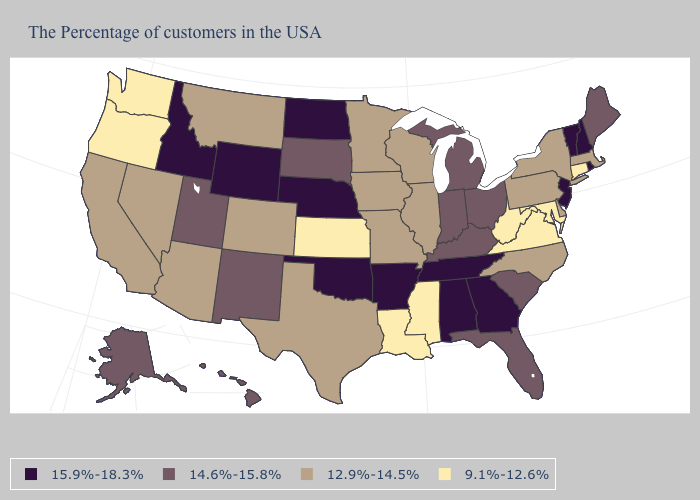Name the states that have a value in the range 15.9%-18.3%?
Concise answer only. Rhode Island, New Hampshire, Vermont, New Jersey, Georgia, Alabama, Tennessee, Arkansas, Nebraska, Oklahoma, North Dakota, Wyoming, Idaho. Name the states that have a value in the range 12.9%-14.5%?
Keep it brief. Massachusetts, New York, Delaware, Pennsylvania, North Carolina, Wisconsin, Illinois, Missouri, Minnesota, Iowa, Texas, Colorado, Montana, Arizona, Nevada, California. Name the states that have a value in the range 9.1%-12.6%?
Answer briefly. Connecticut, Maryland, Virginia, West Virginia, Mississippi, Louisiana, Kansas, Washington, Oregon. Among the states that border Rhode Island , does Connecticut have the lowest value?
Be succinct. Yes. Among the states that border Kansas , which have the highest value?
Concise answer only. Nebraska, Oklahoma. Does Arkansas have the same value as Texas?
Short answer required. No. Which states hav the highest value in the West?
Keep it brief. Wyoming, Idaho. Does Rhode Island have the highest value in the Northeast?
Keep it brief. Yes. Which states have the lowest value in the Northeast?
Concise answer only. Connecticut. What is the value of Pennsylvania?
Give a very brief answer. 12.9%-14.5%. Among the states that border Arizona , which have the lowest value?
Give a very brief answer. Colorado, Nevada, California. What is the value of Colorado?
Keep it brief. 12.9%-14.5%. Does the map have missing data?
Write a very short answer. No. Does Kentucky have the same value as Ohio?
Concise answer only. Yes. Name the states that have a value in the range 9.1%-12.6%?
Answer briefly. Connecticut, Maryland, Virginia, West Virginia, Mississippi, Louisiana, Kansas, Washington, Oregon. 